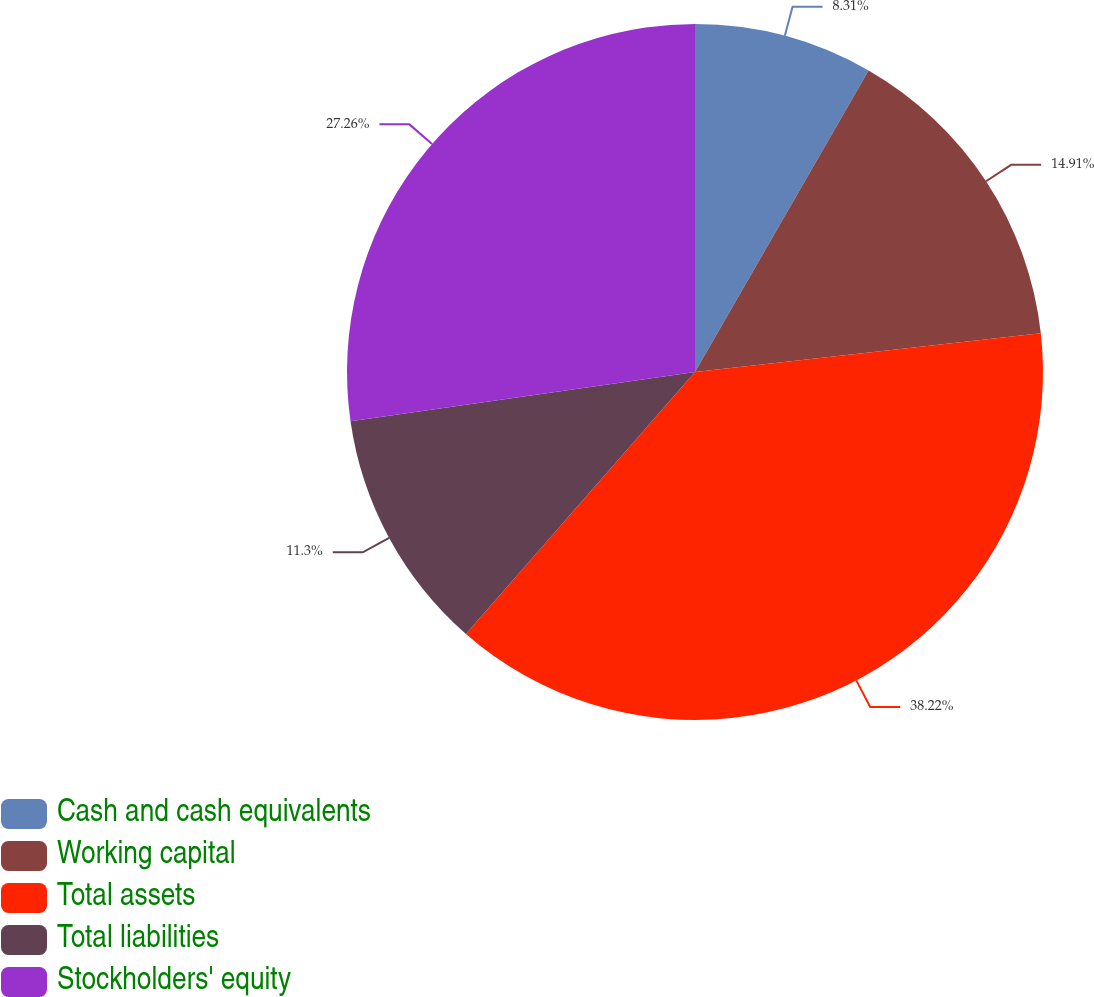Convert chart. <chart><loc_0><loc_0><loc_500><loc_500><pie_chart><fcel>Cash and cash equivalents<fcel>Working capital<fcel>Total assets<fcel>Total liabilities<fcel>Stockholders' equity<nl><fcel>8.31%<fcel>14.91%<fcel>38.21%<fcel>11.3%<fcel>27.26%<nl></chart> 